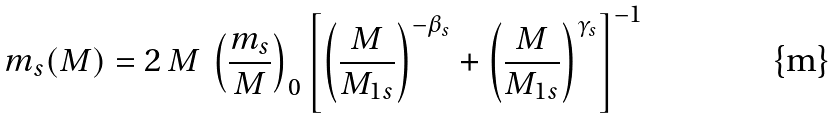Convert formula to latex. <formula><loc_0><loc_0><loc_500><loc_500>m _ { s } ( M ) = 2 \, M \, \left ( \frac { m _ { s } } { M } \right ) _ { 0 } \left [ \left ( \frac { M } { M _ { 1 s } } \right ) ^ { - \beta _ { s } } + \left ( \frac { M } { M _ { 1 s } } \right ) ^ { \gamma _ { s } } \right ] ^ { - 1 }</formula> 